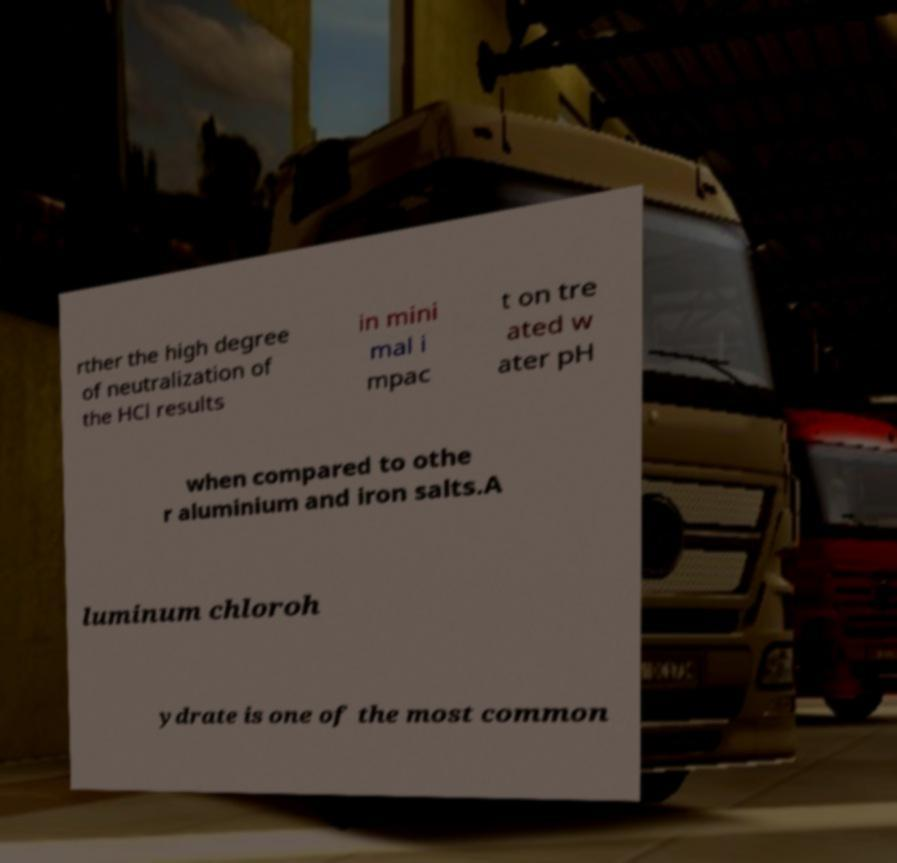Could you assist in decoding the text presented in this image and type it out clearly? rther the high degree of neutralization of the HCl results in mini mal i mpac t on tre ated w ater pH when compared to othe r aluminium and iron salts.A luminum chloroh ydrate is one of the most common 